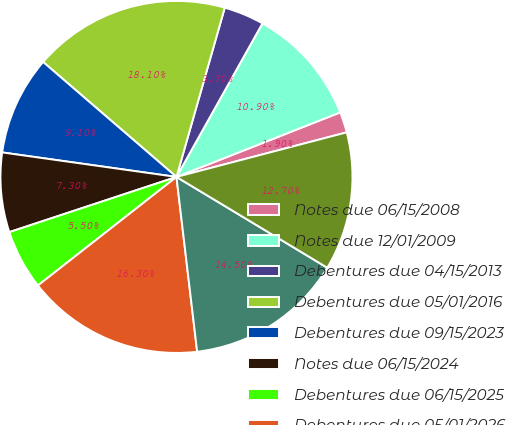Convert chart. <chart><loc_0><loc_0><loc_500><loc_500><pie_chart><fcel>Notes due 06/15/2008<fcel>Notes due 12/01/2009<fcel>Debentures due 04/15/2013<fcel>Debentures due 05/01/2016<fcel>Debentures due 09/15/2023<fcel>Notes due 06/15/2024<fcel>Debentures due 06/15/2025<fcel>Debentures due 05/01/2026<fcel>Debentures due 12/01/2029<fcel>Debentures due 05/01/2036<nl><fcel>1.9%<fcel>10.9%<fcel>3.7%<fcel>18.1%<fcel>9.1%<fcel>7.3%<fcel>5.5%<fcel>16.3%<fcel>14.5%<fcel>12.7%<nl></chart> 